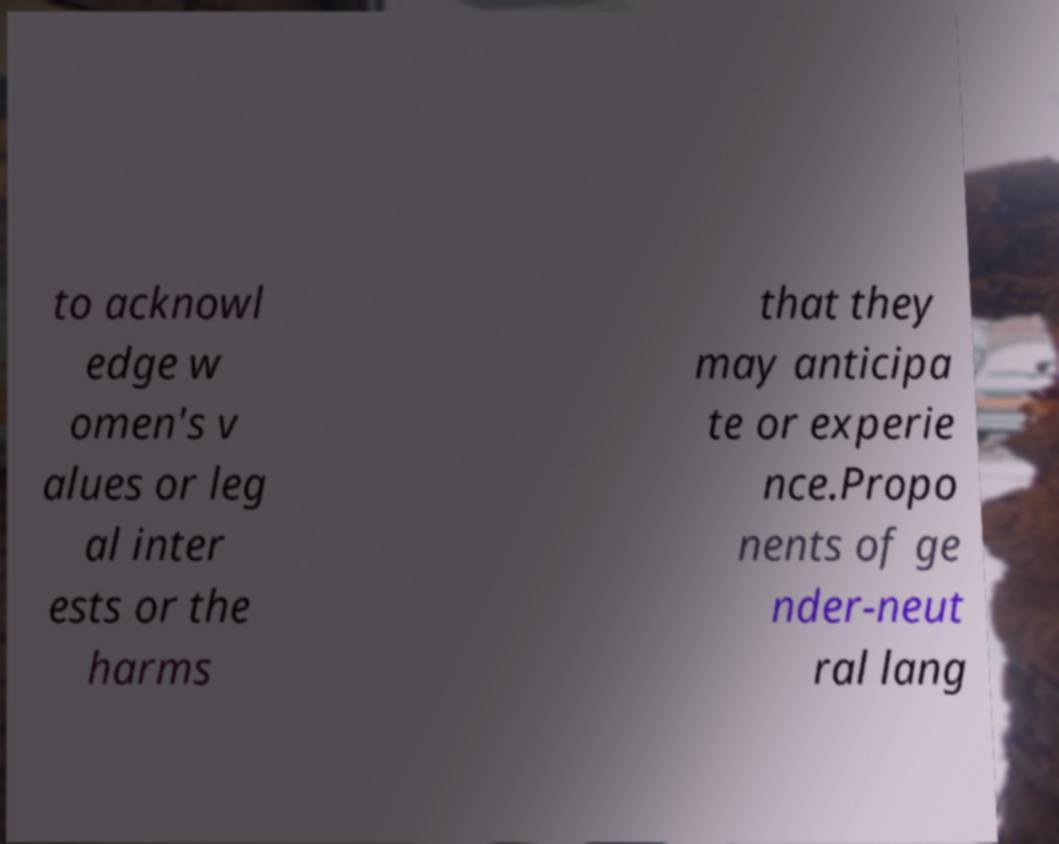For documentation purposes, I need the text within this image transcribed. Could you provide that? to acknowl edge w omen's v alues or leg al inter ests or the harms that they may anticipa te or experie nce.Propo nents of ge nder-neut ral lang 